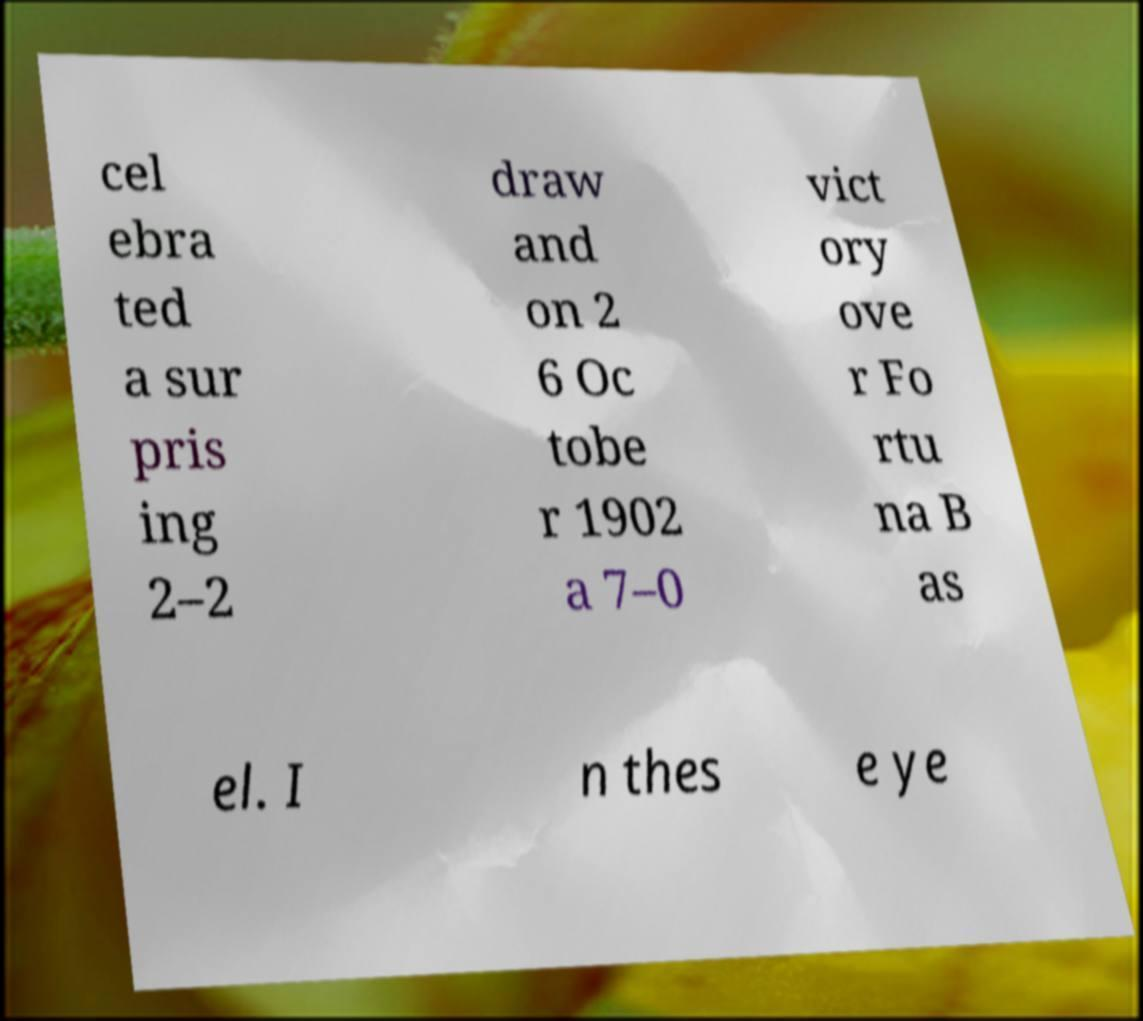What messages or text are displayed in this image? I need them in a readable, typed format. cel ebra ted a sur pris ing 2–2 draw and on 2 6 Oc tobe r 1902 a 7–0 vict ory ove r Fo rtu na B as el. I n thes e ye 